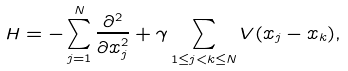<formula> <loc_0><loc_0><loc_500><loc_500>H = - \sum _ { j = 1 } ^ { N } \frac { \partial ^ { 2 } } { \partial x _ { j } ^ { 2 } } + \gamma \sum _ { 1 \leq j < k \leq N } V ( x _ { j } - x _ { k } ) ,</formula> 